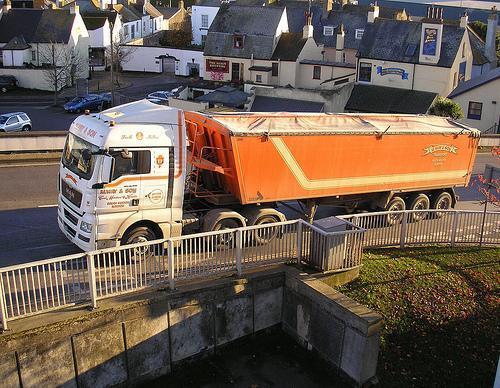How many trucks have wings in the picture?
Give a very brief answer. 0. 